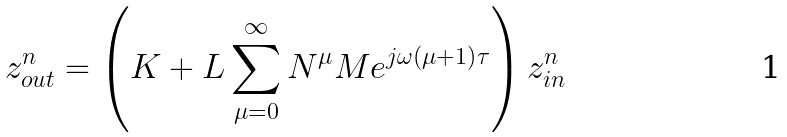<formula> <loc_0><loc_0><loc_500><loc_500>z _ { o u t } ^ { n } = \left ( K + L \sum _ { \mu = 0 } ^ { \infty } N ^ { \mu } M e ^ { j \omega \left ( \mu + 1 \right ) \tau } \right ) z _ { i n } ^ { n }</formula> 